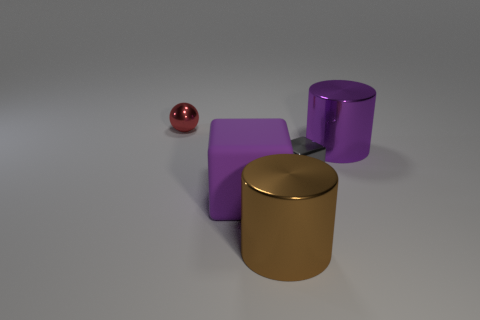There is a purple thing right of the large brown metallic object; how big is it?
Your answer should be compact. Large. Are there any other things of the same color as the ball?
Offer a very short reply. No. Does the cylinder that is behind the tiny gray block have the same material as the big brown thing?
Offer a terse response. Yes. How many purple things are right of the big brown shiny cylinder and in front of the gray object?
Your answer should be very brief. 0. What is the size of the cylinder that is left of the tiny thing that is in front of the tiny sphere?
Provide a short and direct response. Large. Is there anything else that has the same material as the tiny red object?
Offer a terse response. Yes. Are there more tiny gray matte spheres than large purple matte cubes?
Your answer should be compact. No. Is the color of the metallic cylinder in front of the big purple metallic cylinder the same as the tiny object behind the purple cylinder?
Provide a succinct answer. No. There is a tiny red shiny thing behind the brown metallic cylinder; is there a tiny object that is left of it?
Your response must be concise. No. Is the number of small objects that are on the right side of the tiny gray thing less than the number of small things right of the red metallic sphere?
Make the answer very short. Yes. 